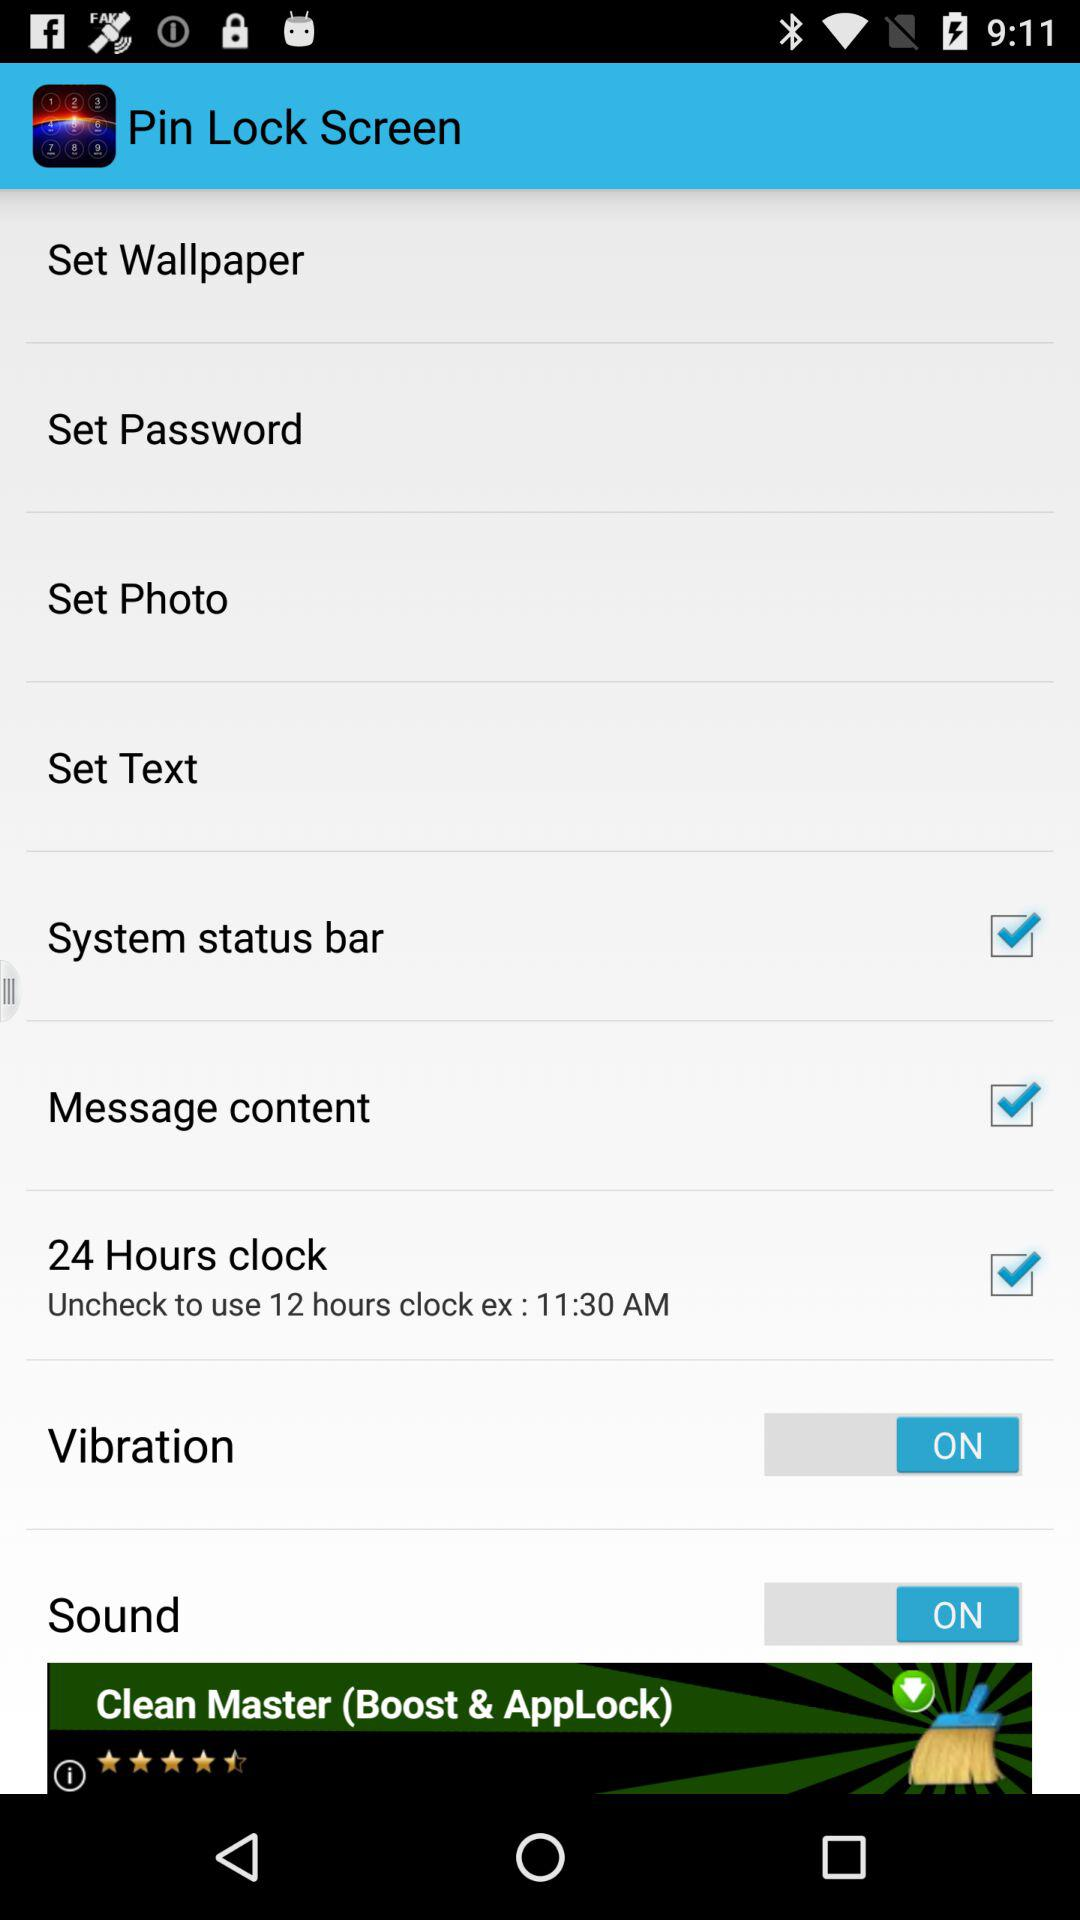What is the status of "Vibration" settings? The status is "on". 